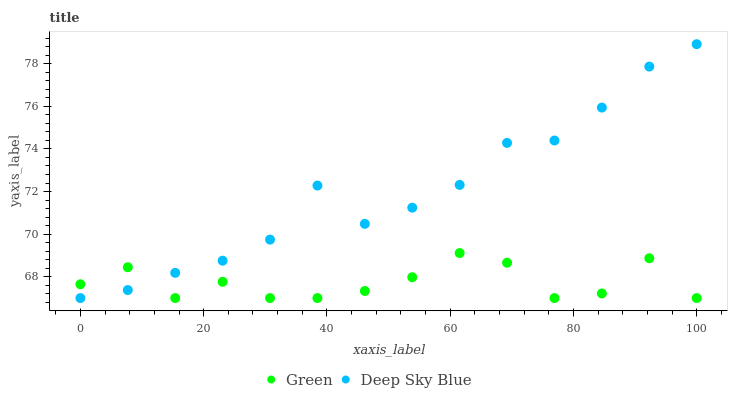Does Green have the minimum area under the curve?
Answer yes or no. Yes. Does Deep Sky Blue have the maximum area under the curve?
Answer yes or no. Yes. Does Deep Sky Blue have the minimum area under the curve?
Answer yes or no. No. Is Deep Sky Blue the smoothest?
Answer yes or no. Yes. Is Green the roughest?
Answer yes or no. Yes. Is Deep Sky Blue the roughest?
Answer yes or no. No. Does Green have the lowest value?
Answer yes or no. Yes. Does Deep Sky Blue have the highest value?
Answer yes or no. Yes. Does Deep Sky Blue intersect Green?
Answer yes or no. Yes. Is Deep Sky Blue less than Green?
Answer yes or no. No. Is Deep Sky Blue greater than Green?
Answer yes or no. No. 